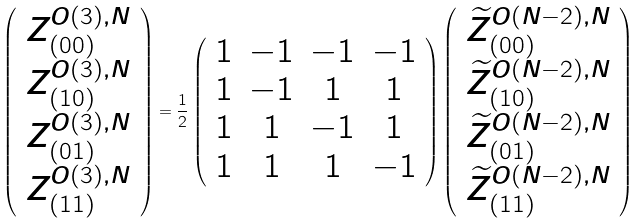Convert formula to latex. <formula><loc_0><loc_0><loc_500><loc_500>\left ( \begin{array} { c } Z ^ { O ( 3 ) , N } _ { ( 0 0 ) } \\ Z ^ { O ( 3 ) , N } _ { ( 1 0 ) } \\ Z ^ { O ( 3 ) , N } _ { ( 0 1 ) } \\ Z ^ { O ( 3 ) , N } _ { ( 1 1 ) } \\ \end{array} \right ) = \frac { 1 } { 2 } \left ( \begin{array} { c c c c } 1 & - 1 & - 1 & - 1 \\ 1 & - 1 & 1 & 1 \\ 1 & 1 & - 1 & 1 \\ 1 & 1 & 1 & - 1 \\ \end{array} \right ) \left ( \begin{array} { c } \widetilde { Z } ^ { O ( N - 2 ) , N } _ { ( 0 0 ) } \\ \widetilde { Z } ^ { O ( N - 2 ) , N } _ { ( 1 0 ) } \\ \widetilde { Z } ^ { O ( N - 2 ) , N } _ { ( 0 1 ) } \\ \widetilde { Z } ^ { O ( N - 2 ) , N } _ { ( 1 1 ) } \\ \end{array} \right )</formula> 